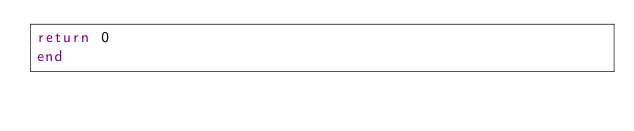<code> <loc_0><loc_0><loc_500><loc_500><_FORTRAN_>return 0
end
</code> 